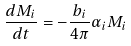Convert formula to latex. <formula><loc_0><loc_0><loc_500><loc_500>\frac { d M _ { i } } { d t } = - \frac { b _ { i } } { 4 \pi } \alpha _ { i } M _ { i }</formula> 